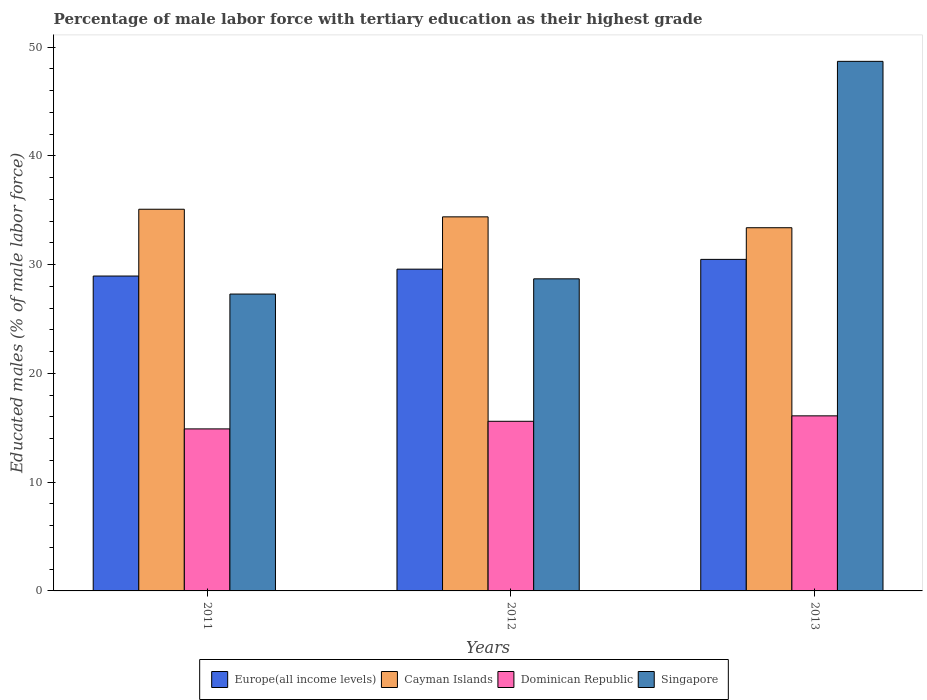Are the number of bars per tick equal to the number of legend labels?
Your answer should be very brief. Yes. Are the number of bars on each tick of the X-axis equal?
Offer a terse response. Yes. How many bars are there on the 2nd tick from the left?
Your answer should be very brief. 4. In how many cases, is the number of bars for a given year not equal to the number of legend labels?
Offer a terse response. 0. What is the percentage of male labor force with tertiary education in Singapore in 2012?
Your response must be concise. 28.7. Across all years, what is the maximum percentage of male labor force with tertiary education in Cayman Islands?
Make the answer very short. 35.1. Across all years, what is the minimum percentage of male labor force with tertiary education in Dominican Republic?
Give a very brief answer. 14.9. In which year was the percentage of male labor force with tertiary education in Cayman Islands minimum?
Keep it short and to the point. 2013. What is the total percentage of male labor force with tertiary education in Cayman Islands in the graph?
Ensure brevity in your answer.  102.9. What is the difference between the percentage of male labor force with tertiary education in Singapore in 2011 and that in 2013?
Provide a short and direct response. -21.4. What is the difference between the percentage of male labor force with tertiary education in Singapore in 2011 and the percentage of male labor force with tertiary education in Dominican Republic in 2012?
Offer a terse response. 11.7. What is the average percentage of male labor force with tertiary education in Cayman Islands per year?
Your response must be concise. 34.3. In the year 2012, what is the difference between the percentage of male labor force with tertiary education in Singapore and percentage of male labor force with tertiary education in Cayman Islands?
Your answer should be very brief. -5.7. In how many years, is the percentage of male labor force with tertiary education in Cayman Islands greater than 20 %?
Make the answer very short. 3. What is the ratio of the percentage of male labor force with tertiary education in Singapore in 2011 to that in 2013?
Provide a short and direct response. 0.56. What is the difference between the highest and the second highest percentage of male labor force with tertiary education in Dominican Republic?
Provide a short and direct response. 0.5. What is the difference between the highest and the lowest percentage of male labor force with tertiary education in Singapore?
Offer a very short reply. 21.4. In how many years, is the percentage of male labor force with tertiary education in Europe(all income levels) greater than the average percentage of male labor force with tertiary education in Europe(all income levels) taken over all years?
Your response must be concise. 1. Is it the case that in every year, the sum of the percentage of male labor force with tertiary education in Europe(all income levels) and percentage of male labor force with tertiary education in Dominican Republic is greater than the sum of percentage of male labor force with tertiary education in Singapore and percentage of male labor force with tertiary education in Cayman Islands?
Keep it short and to the point. No. What does the 1st bar from the left in 2013 represents?
Keep it short and to the point. Europe(all income levels). What does the 4th bar from the right in 2011 represents?
Your response must be concise. Europe(all income levels). Is it the case that in every year, the sum of the percentage of male labor force with tertiary education in Cayman Islands and percentage of male labor force with tertiary education in Dominican Republic is greater than the percentage of male labor force with tertiary education in Singapore?
Your answer should be compact. Yes. How many bars are there?
Your answer should be very brief. 12. What is the difference between two consecutive major ticks on the Y-axis?
Offer a terse response. 10. Are the values on the major ticks of Y-axis written in scientific E-notation?
Provide a succinct answer. No. How are the legend labels stacked?
Make the answer very short. Horizontal. What is the title of the graph?
Your answer should be very brief. Percentage of male labor force with tertiary education as their highest grade. Does "Bahamas" appear as one of the legend labels in the graph?
Offer a terse response. No. What is the label or title of the X-axis?
Keep it short and to the point. Years. What is the label or title of the Y-axis?
Keep it short and to the point. Educated males (% of male labor force). What is the Educated males (% of male labor force) in Europe(all income levels) in 2011?
Your answer should be compact. 28.96. What is the Educated males (% of male labor force) of Cayman Islands in 2011?
Provide a short and direct response. 35.1. What is the Educated males (% of male labor force) of Dominican Republic in 2011?
Give a very brief answer. 14.9. What is the Educated males (% of male labor force) of Singapore in 2011?
Ensure brevity in your answer.  27.3. What is the Educated males (% of male labor force) in Europe(all income levels) in 2012?
Offer a terse response. 29.59. What is the Educated males (% of male labor force) of Cayman Islands in 2012?
Make the answer very short. 34.4. What is the Educated males (% of male labor force) in Dominican Republic in 2012?
Give a very brief answer. 15.6. What is the Educated males (% of male labor force) of Singapore in 2012?
Provide a succinct answer. 28.7. What is the Educated males (% of male labor force) in Europe(all income levels) in 2013?
Ensure brevity in your answer.  30.49. What is the Educated males (% of male labor force) of Cayman Islands in 2013?
Make the answer very short. 33.4. What is the Educated males (% of male labor force) of Dominican Republic in 2013?
Your answer should be very brief. 16.1. What is the Educated males (% of male labor force) of Singapore in 2013?
Provide a succinct answer. 48.7. Across all years, what is the maximum Educated males (% of male labor force) in Europe(all income levels)?
Your response must be concise. 30.49. Across all years, what is the maximum Educated males (% of male labor force) of Cayman Islands?
Keep it short and to the point. 35.1. Across all years, what is the maximum Educated males (% of male labor force) of Dominican Republic?
Offer a terse response. 16.1. Across all years, what is the maximum Educated males (% of male labor force) in Singapore?
Give a very brief answer. 48.7. Across all years, what is the minimum Educated males (% of male labor force) in Europe(all income levels)?
Your answer should be very brief. 28.96. Across all years, what is the minimum Educated males (% of male labor force) in Cayman Islands?
Provide a succinct answer. 33.4. Across all years, what is the minimum Educated males (% of male labor force) in Dominican Republic?
Your answer should be compact. 14.9. Across all years, what is the minimum Educated males (% of male labor force) of Singapore?
Give a very brief answer. 27.3. What is the total Educated males (% of male labor force) of Europe(all income levels) in the graph?
Your response must be concise. 89.04. What is the total Educated males (% of male labor force) of Cayman Islands in the graph?
Offer a terse response. 102.9. What is the total Educated males (% of male labor force) in Dominican Republic in the graph?
Keep it short and to the point. 46.6. What is the total Educated males (% of male labor force) in Singapore in the graph?
Your response must be concise. 104.7. What is the difference between the Educated males (% of male labor force) in Europe(all income levels) in 2011 and that in 2012?
Make the answer very short. -0.63. What is the difference between the Educated males (% of male labor force) in Cayman Islands in 2011 and that in 2012?
Offer a terse response. 0.7. What is the difference between the Educated males (% of male labor force) in Dominican Republic in 2011 and that in 2012?
Your answer should be compact. -0.7. What is the difference between the Educated males (% of male labor force) of Singapore in 2011 and that in 2012?
Keep it short and to the point. -1.4. What is the difference between the Educated males (% of male labor force) in Europe(all income levels) in 2011 and that in 2013?
Your answer should be compact. -1.53. What is the difference between the Educated males (% of male labor force) of Singapore in 2011 and that in 2013?
Your response must be concise. -21.4. What is the difference between the Educated males (% of male labor force) in Europe(all income levels) in 2012 and that in 2013?
Provide a succinct answer. -0.9. What is the difference between the Educated males (% of male labor force) in Cayman Islands in 2012 and that in 2013?
Offer a very short reply. 1. What is the difference between the Educated males (% of male labor force) in Dominican Republic in 2012 and that in 2013?
Ensure brevity in your answer.  -0.5. What is the difference between the Educated males (% of male labor force) in Singapore in 2012 and that in 2013?
Provide a short and direct response. -20. What is the difference between the Educated males (% of male labor force) in Europe(all income levels) in 2011 and the Educated males (% of male labor force) in Cayman Islands in 2012?
Give a very brief answer. -5.44. What is the difference between the Educated males (% of male labor force) of Europe(all income levels) in 2011 and the Educated males (% of male labor force) of Dominican Republic in 2012?
Your answer should be compact. 13.36. What is the difference between the Educated males (% of male labor force) of Europe(all income levels) in 2011 and the Educated males (% of male labor force) of Singapore in 2012?
Provide a short and direct response. 0.26. What is the difference between the Educated males (% of male labor force) in Cayman Islands in 2011 and the Educated males (% of male labor force) in Dominican Republic in 2012?
Your answer should be compact. 19.5. What is the difference between the Educated males (% of male labor force) in Dominican Republic in 2011 and the Educated males (% of male labor force) in Singapore in 2012?
Your response must be concise. -13.8. What is the difference between the Educated males (% of male labor force) of Europe(all income levels) in 2011 and the Educated males (% of male labor force) of Cayman Islands in 2013?
Provide a succinct answer. -4.44. What is the difference between the Educated males (% of male labor force) of Europe(all income levels) in 2011 and the Educated males (% of male labor force) of Dominican Republic in 2013?
Offer a very short reply. 12.86. What is the difference between the Educated males (% of male labor force) of Europe(all income levels) in 2011 and the Educated males (% of male labor force) of Singapore in 2013?
Provide a short and direct response. -19.74. What is the difference between the Educated males (% of male labor force) in Cayman Islands in 2011 and the Educated males (% of male labor force) in Dominican Republic in 2013?
Keep it short and to the point. 19. What is the difference between the Educated males (% of male labor force) in Dominican Republic in 2011 and the Educated males (% of male labor force) in Singapore in 2013?
Your response must be concise. -33.8. What is the difference between the Educated males (% of male labor force) in Europe(all income levels) in 2012 and the Educated males (% of male labor force) in Cayman Islands in 2013?
Give a very brief answer. -3.81. What is the difference between the Educated males (% of male labor force) of Europe(all income levels) in 2012 and the Educated males (% of male labor force) of Dominican Republic in 2013?
Give a very brief answer. 13.49. What is the difference between the Educated males (% of male labor force) in Europe(all income levels) in 2012 and the Educated males (% of male labor force) in Singapore in 2013?
Make the answer very short. -19.11. What is the difference between the Educated males (% of male labor force) of Cayman Islands in 2012 and the Educated males (% of male labor force) of Dominican Republic in 2013?
Keep it short and to the point. 18.3. What is the difference between the Educated males (% of male labor force) of Cayman Islands in 2012 and the Educated males (% of male labor force) of Singapore in 2013?
Provide a succinct answer. -14.3. What is the difference between the Educated males (% of male labor force) of Dominican Republic in 2012 and the Educated males (% of male labor force) of Singapore in 2013?
Give a very brief answer. -33.1. What is the average Educated males (% of male labor force) of Europe(all income levels) per year?
Offer a terse response. 29.68. What is the average Educated males (% of male labor force) in Cayman Islands per year?
Offer a terse response. 34.3. What is the average Educated males (% of male labor force) in Dominican Republic per year?
Offer a very short reply. 15.53. What is the average Educated males (% of male labor force) in Singapore per year?
Provide a succinct answer. 34.9. In the year 2011, what is the difference between the Educated males (% of male labor force) of Europe(all income levels) and Educated males (% of male labor force) of Cayman Islands?
Provide a succinct answer. -6.14. In the year 2011, what is the difference between the Educated males (% of male labor force) in Europe(all income levels) and Educated males (% of male labor force) in Dominican Republic?
Keep it short and to the point. 14.06. In the year 2011, what is the difference between the Educated males (% of male labor force) in Europe(all income levels) and Educated males (% of male labor force) in Singapore?
Your answer should be compact. 1.66. In the year 2011, what is the difference between the Educated males (% of male labor force) of Cayman Islands and Educated males (% of male labor force) of Dominican Republic?
Your answer should be compact. 20.2. In the year 2011, what is the difference between the Educated males (% of male labor force) of Cayman Islands and Educated males (% of male labor force) of Singapore?
Make the answer very short. 7.8. In the year 2011, what is the difference between the Educated males (% of male labor force) in Dominican Republic and Educated males (% of male labor force) in Singapore?
Provide a short and direct response. -12.4. In the year 2012, what is the difference between the Educated males (% of male labor force) in Europe(all income levels) and Educated males (% of male labor force) in Cayman Islands?
Provide a succinct answer. -4.81. In the year 2012, what is the difference between the Educated males (% of male labor force) in Europe(all income levels) and Educated males (% of male labor force) in Dominican Republic?
Give a very brief answer. 13.99. In the year 2012, what is the difference between the Educated males (% of male labor force) of Europe(all income levels) and Educated males (% of male labor force) of Singapore?
Keep it short and to the point. 0.89. In the year 2012, what is the difference between the Educated males (% of male labor force) in Cayman Islands and Educated males (% of male labor force) in Dominican Republic?
Offer a very short reply. 18.8. In the year 2013, what is the difference between the Educated males (% of male labor force) of Europe(all income levels) and Educated males (% of male labor force) of Cayman Islands?
Make the answer very short. -2.91. In the year 2013, what is the difference between the Educated males (% of male labor force) of Europe(all income levels) and Educated males (% of male labor force) of Dominican Republic?
Make the answer very short. 14.39. In the year 2013, what is the difference between the Educated males (% of male labor force) of Europe(all income levels) and Educated males (% of male labor force) of Singapore?
Provide a succinct answer. -18.21. In the year 2013, what is the difference between the Educated males (% of male labor force) of Cayman Islands and Educated males (% of male labor force) of Singapore?
Offer a terse response. -15.3. In the year 2013, what is the difference between the Educated males (% of male labor force) in Dominican Republic and Educated males (% of male labor force) in Singapore?
Ensure brevity in your answer.  -32.6. What is the ratio of the Educated males (% of male labor force) of Europe(all income levels) in 2011 to that in 2012?
Offer a terse response. 0.98. What is the ratio of the Educated males (% of male labor force) in Cayman Islands in 2011 to that in 2012?
Your response must be concise. 1.02. What is the ratio of the Educated males (% of male labor force) of Dominican Republic in 2011 to that in 2012?
Offer a terse response. 0.96. What is the ratio of the Educated males (% of male labor force) in Singapore in 2011 to that in 2012?
Keep it short and to the point. 0.95. What is the ratio of the Educated males (% of male labor force) in Europe(all income levels) in 2011 to that in 2013?
Your answer should be compact. 0.95. What is the ratio of the Educated males (% of male labor force) in Cayman Islands in 2011 to that in 2013?
Offer a terse response. 1.05. What is the ratio of the Educated males (% of male labor force) of Dominican Republic in 2011 to that in 2013?
Your answer should be compact. 0.93. What is the ratio of the Educated males (% of male labor force) of Singapore in 2011 to that in 2013?
Provide a succinct answer. 0.56. What is the ratio of the Educated males (% of male labor force) in Europe(all income levels) in 2012 to that in 2013?
Make the answer very short. 0.97. What is the ratio of the Educated males (% of male labor force) of Cayman Islands in 2012 to that in 2013?
Your response must be concise. 1.03. What is the ratio of the Educated males (% of male labor force) in Dominican Republic in 2012 to that in 2013?
Provide a short and direct response. 0.97. What is the ratio of the Educated males (% of male labor force) of Singapore in 2012 to that in 2013?
Keep it short and to the point. 0.59. What is the difference between the highest and the second highest Educated males (% of male labor force) of Europe(all income levels)?
Your response must be concise. 0.9. What is the difference between the highest and the second highest Educated males (% of male labor force) in Cayman Islands?
Give a very brief answer. 0.7. What is the difference between the highest and the second highest Educated males (% of male labor force) of Singapore?
Give a very brief answer. 20. What is the difference between the highest and the lowest Educated males (% of male labor force) in Europe(all income levels)?
Your answer should be very brief. 1.53. What is the difference between the highest and the lowest Educated males (% of male labor force) of Cayman Islands?
Keep it short and to the point. 1.7. What is the difference between the highest and the lowest Educated males (% of male labor force) of Singapore?
Give a very brief answer. 21.4. 